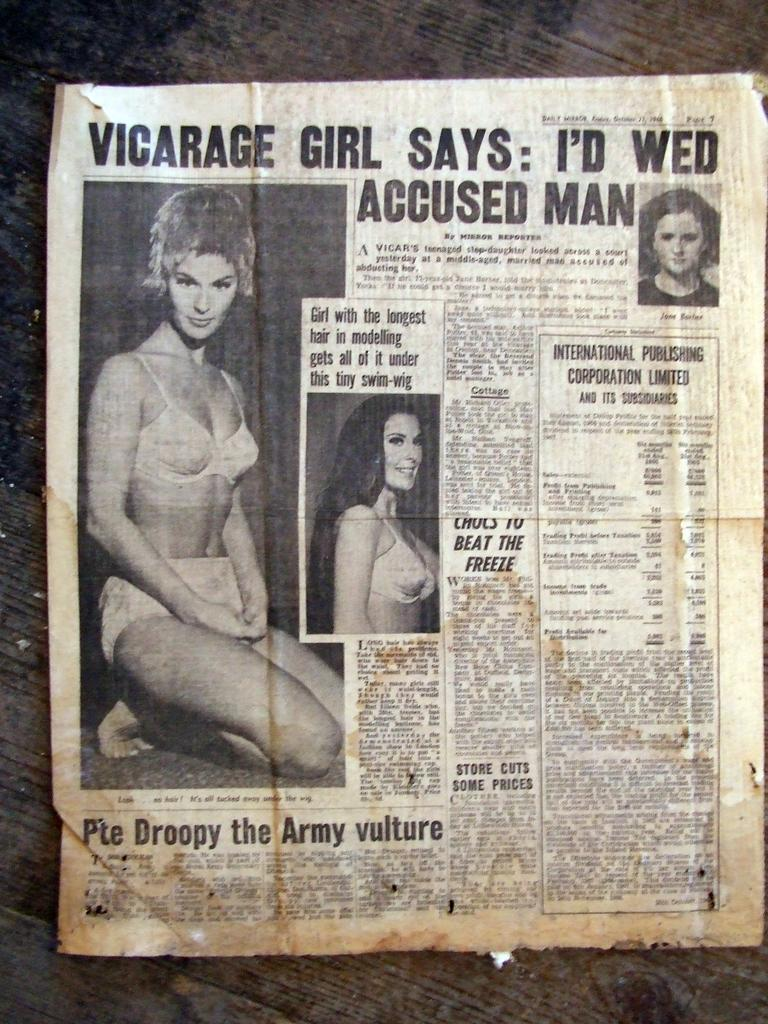What is the main object in the image? There is a newspaper in the image. What can be found within the newspaper? The newspaper contains images and text. What type of calculator is shown in the image? There is no calculator present in the image; it only features a newspaper with images and text. 